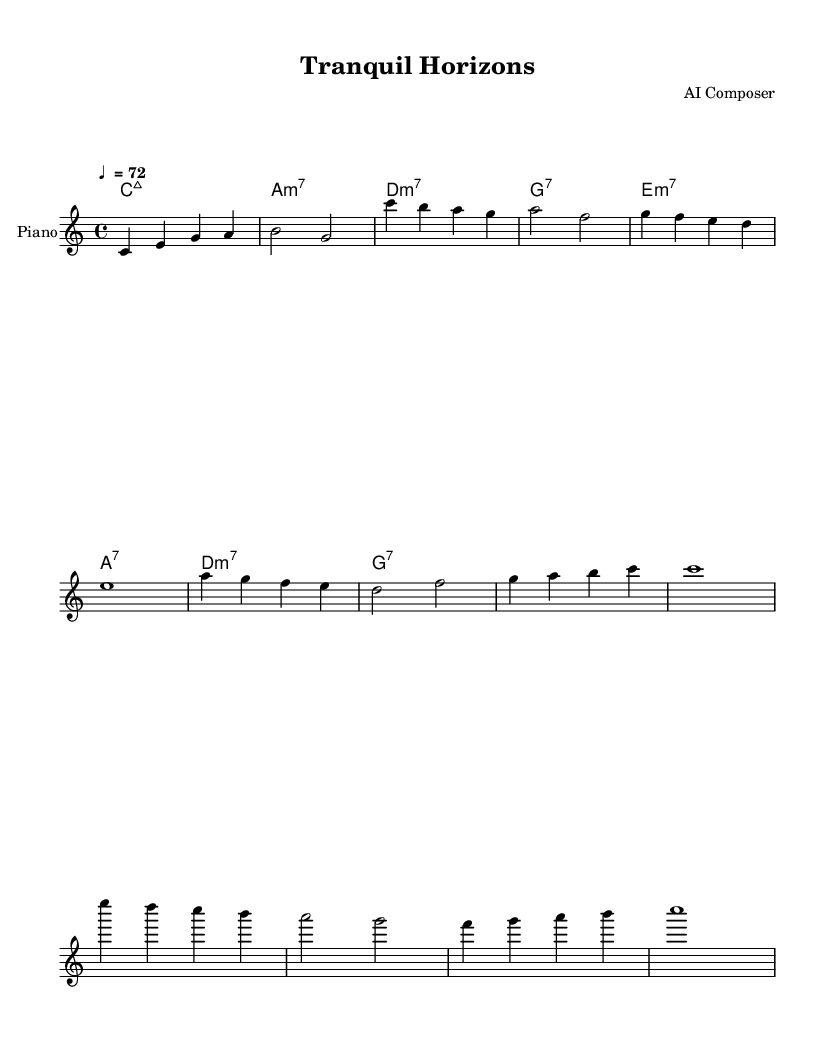What is the key signature of this music? The key signature is C major, which has no sharps or flats.
Answer: C major What is the time signature of this music? The time signature is indicated by the ‘4/4’ marking at the beginning, representing four beats in each measure.
Answer: 4/4 What is the tempo marking? The tempo marking is indicated by the text "♩ = 72", meaning there are 72 beats per minute.
Answer: ♩ = 72 How many measures are in the bridge section? The bridge section has four measures, which can be counted by looking at the grouping of notes and the vertical lines separating them.
Answer: 4 Which chords are used in the chorus? The chords in the chorus are derived from the harmonic section marked by letters following the chord symbols: a, f, e, d, g, b, c.
Answer: a, f, e, d, g, b, c What instrument is indicated for the melody? The instrument indicated for the melody is labeled "Piano" in the score.
Answer: Piano What is the last chord of the piece? The last chord is identified as "c1" in the harmonies section, which signifies a C major chord sustained for a whole note.
Answer: C major 